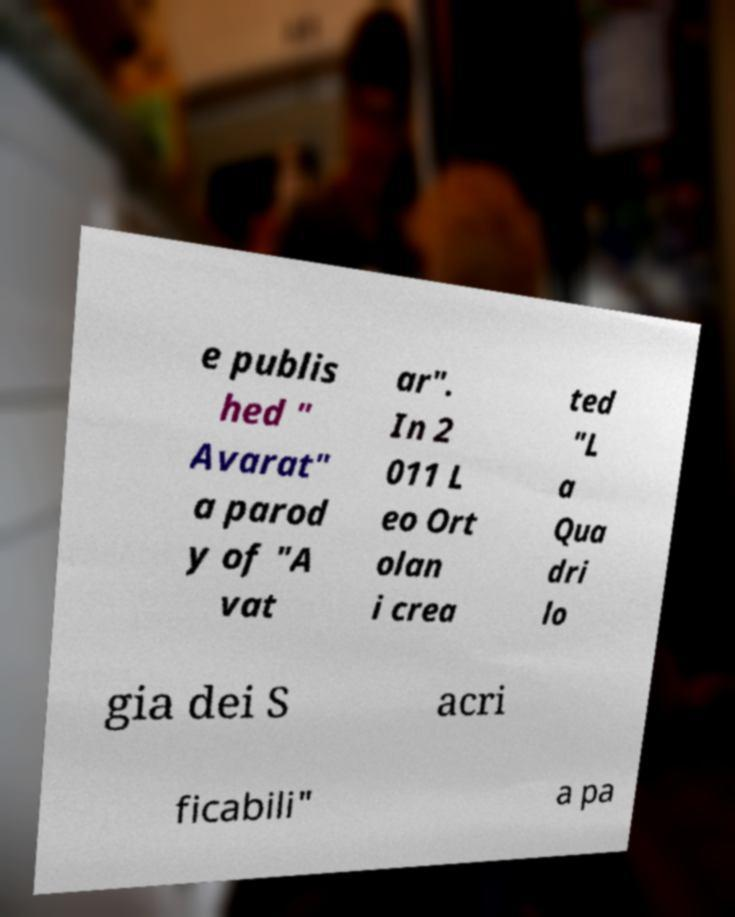Can you read and provide the text displayed in the image?This photo seems to have some interesting text. Can you extract and type it out for me? e publis hed " Avarat" a parod y of "A vat ar". In 2 011 L eo Ort olan i crea ted "L a Qua dri lo gia dei S acri ficabili" a pa 